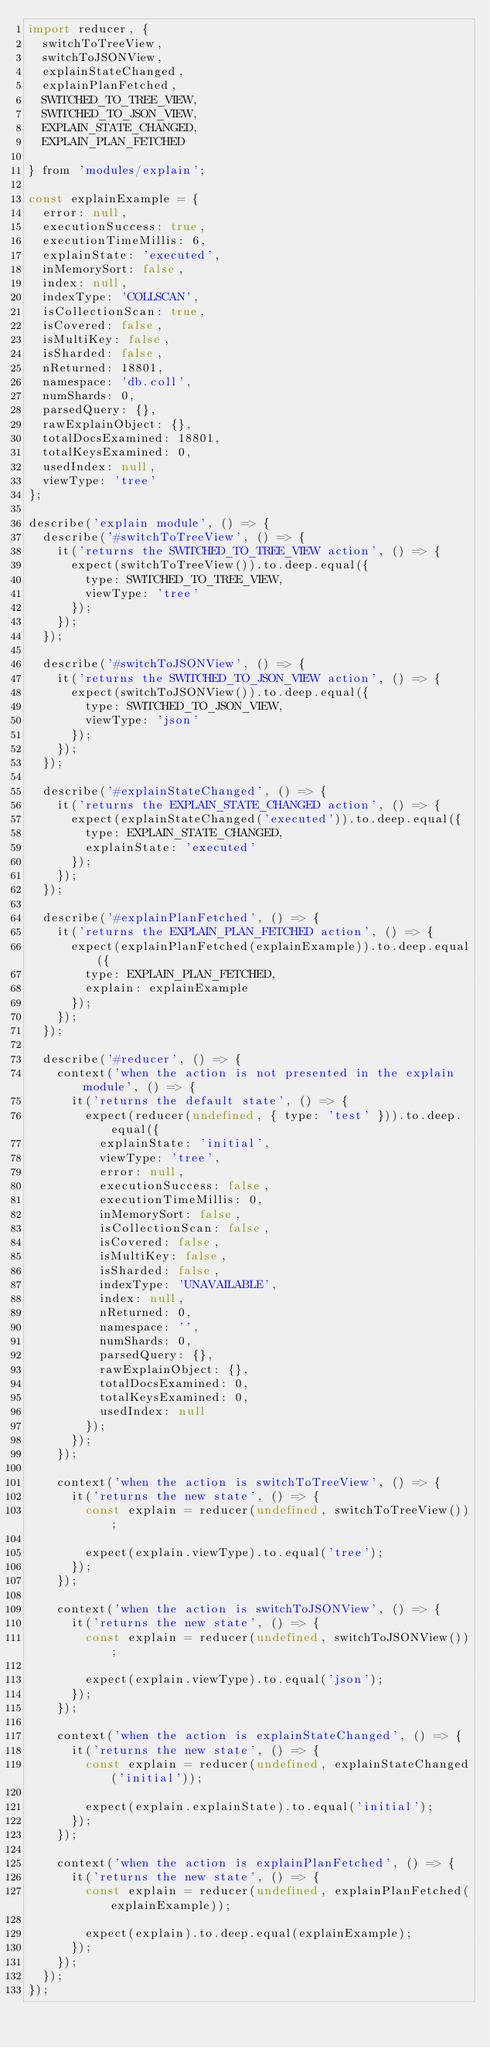Convert code to text. <code><loc_0><loc_0><loc_500><loc_500><_JavaScript_>import reducer, {
  switchToTreeView,
  switchToJSONView,
  explainStateChanged,
  explainPlanFetched,
  SWITCHED_TO_TREE_VIEW,
  SWITCHED_TO_JSON_VIEW,
  EXPLAIN_STATE_CHANGED,
  EXPLAIN_PLAN_FETCHED

} from 'modules/explain';

const explainExample = {
  error: null,
  executionSuccess: true,
  executionTimeMillis: 6,
  explainState: 'executed',
  inMemorySort: false,
  index: null,
  indexType: 'COLLSCAN',
  isCollectionScan: true,
  isCovered: false,
  isMultiKey: false,
  isSharded: false,
  nReturned: 18801,
  namespace: 'db.coll',
  numShards: 0,
  parsedQuery: {},
  rawExplainObject: {},
  totalDocsExamined: 18801,
  totalKeysExamined: 0,
  usedIndex: null,
  viewType: 'tree'
};

describe('explain module', () => {
  describe('#switchToTreeView', () => {
    it('returns the SWITCHED_TO_TREE_VIEW action', () => {
      expect(switchToTreeView()).to.deep.equal({
        type: SWITCHED_TO_TREE_VIEW,
        viewType: 'tree'
      });
    });
  });

  describe('#switchToJSONView', () => {
    it('returns the SWITCHED_TO_JSON_VIEW action', () => {
      expect(switchToJSONView()).to.deep.equal({
        type: SWITCHED_TO_JSON_VIEW,
        viewType: 'json'
      });
    });
  });

  describe('#explainStateChanged', () => {
    it('returns the EXPLAIN_STATE_CHANGED action', () => {
      expect(explainStateChanged('executed')).to.deep.equal({
        type: EXPLAIN_STATE_CHANGED,
        explainState: 'executed'
      });
    });
  });

  describe('#explainPlanFetched', () => {
    it('returns the EXPLAIN_PLAN_FETCHED action', () => {
      expect(explainPlanFetched(explainExample)).to.deep.equal({
        type: EXPLAIN_PLAN_FETCHED,
        explain: explainExample
      });
    });
  });

  describe('#reducer', () => {
    context('when the action is not presented in the explain module', () => {
      it('returns the default state', () => {
        expect(reducer(undefined, { type: 'test' })).to.deep.equal({
          explainState: 'initial',
          viewType: 'tree',
          error: null,
          executionSuccess: false,
          executionTimeMillis: 0,
          inMemorySort: false,
          isCollectionScan: false,
          isCovered: false,
          isMultiKey: false,
          isSharded: false,
          indexType: 'UNAVAILABLE',
          index: null,
          nReturned: 0,
          namespace: '',
          numShards: 0,
          parsedQuery: {},
          rawExplainObject: {},
          totalDocsExamined: 0,
          totalKeysExamined: 0,
          usedIndex: null
        });
      });
    });

    context('when the action is switchToTreeView', () => {
      it('returns the new state', () => {
        const explain = reducer(undefined, switchToTreeView());

        expect(explain.viewType).to.equal('tree');
      });
    });

    context('when the action is switchToJSONView', () => {
      it('returns the new state', () => {
        const explain = reducer(undefined, switchToJSONView());

        expect(explain.viewType).to.equal('json');
      });
    });

    context('when the action is explainStateChanged', () => {
      it('returns the new state', () => {
        const explain = reducer(undefined, explainStateChanged('initial'));

        expect(explain.explainState).to.equal('initial');
      });
    });

    context('when the action is explainPlanFetched', () => {
      it('returns the new state', () => {
        const explain = reducer(undefined, explainPlanFetched(explainExample));

        expect(explain).to.deep.equal(explainExample);
      });
    });
  });
});
</code> 